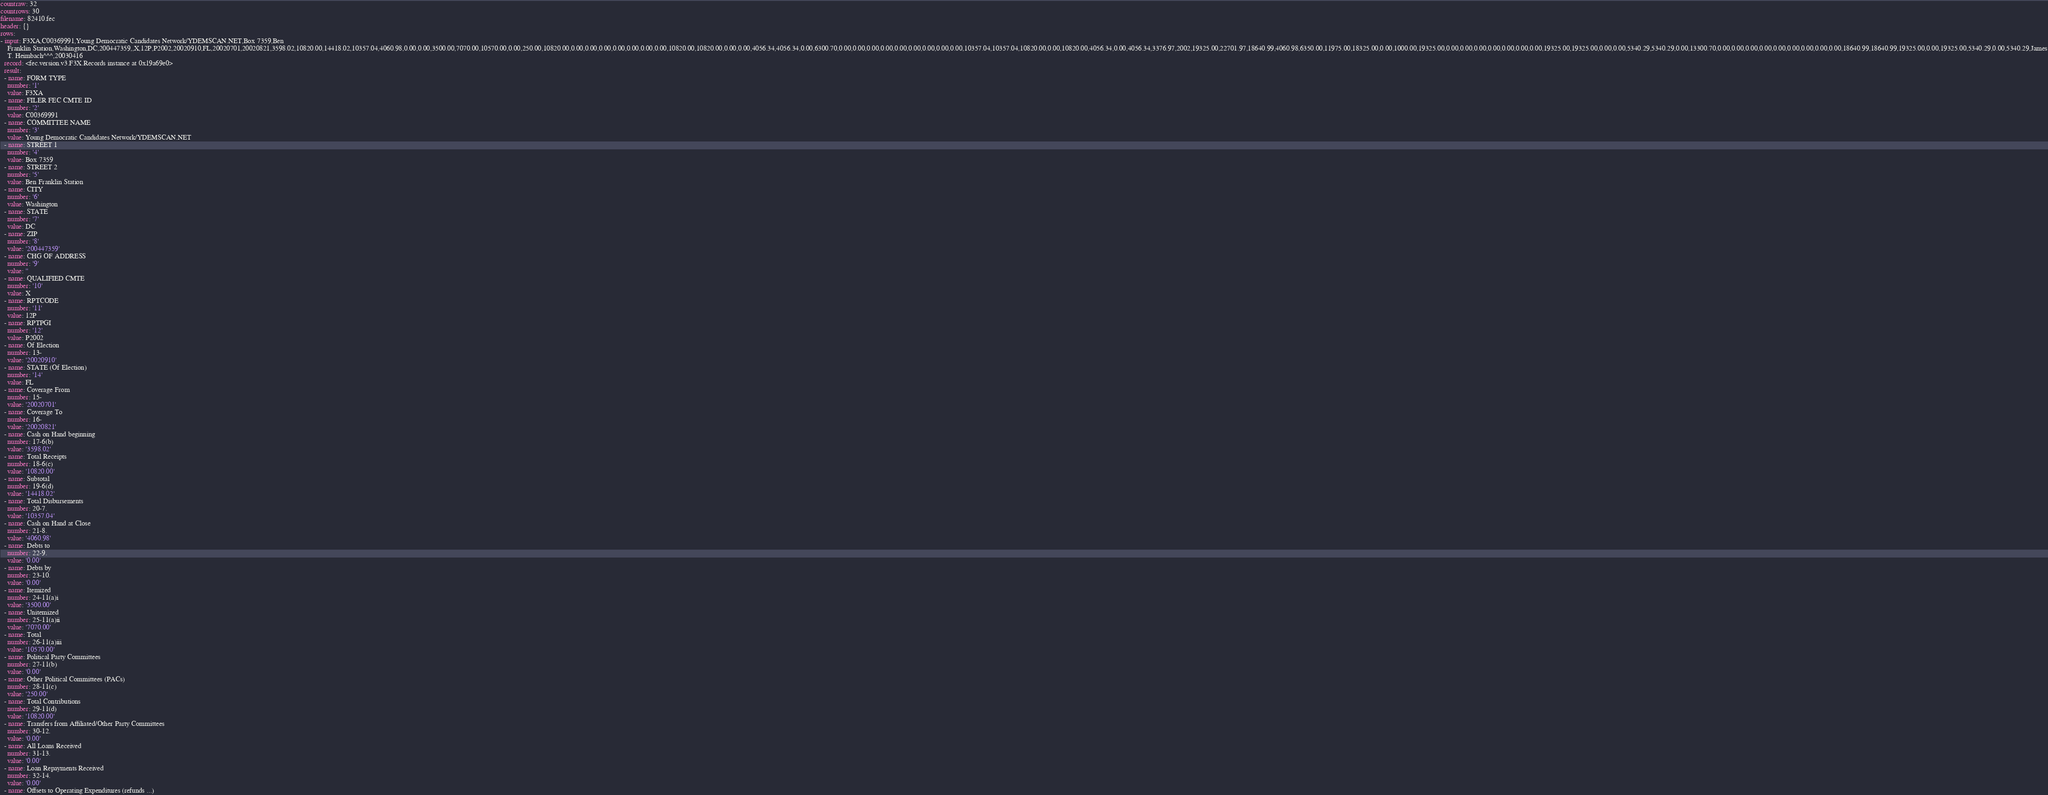<code> <loc_0><loc_0><loc_500><loc_500><_YAML_>countraw: 32
countrows: 30
filename: 82410.fec
header: {}
rows:
- input: F3XA,C00369991,Young Democratic Candidates Network/YDEMSCAN.NET,Box 7359,Ben
    Franklin Station,Washington,DC,200447359,,X,12P,P2002,20020910,FL,20020701,20020821,3598.02,10820.00,14418.02,10357.04,4060.98,0.00,0.00,3500.00,7070.00,10570.00,0.00,250.00,10820.00,0.00,0.00,0.00,0.00,0.00,0.00,0.00,10820.00,10820.00,0.00,0.00,4056.34,4056.34,0.00,6300.70,0.00,0.00,0.00,0.00,0.00,0.00,0.00,0.00,0.00,10357.04,10357.04,10820.00,0.00,10820.00,4056.34,0.00,4056.34,3376.97,2002,19325.00,22701.97,18640.99,4060.98,6350.00,11975.00,18325.00,0.00,1000.00,19325.00,0.00,0.00,0.00,0.00,0.00,0.00,0.00,19325.00,19325.00,0.00,0.00,5340.29,5340.29,0.00,13300.70,0.00,0.00,0.00,0.00,0.00,0.00,0.00,0.00,0.00,18640.99,18640.99,19325.00,0.00,19325.00,5340.29,0.00,5340.29,James
    T. Heimbach^^^,20030416
  record: <fec.version.v3.F3X.Records instance at 0x19a69e0>
  result:
  - name: FORM TYPE
    number: '1'
    value: F3XA
  - name: FILER FEC CMTE ID
    number: '2'
    value: C00369991
  - name: COMMITTEE NAME
    number: '3'
    value: Young Democratic Candidates Network/YDEMSCAN.NET
  - name: STREET 1
    number: '4'
    value: Box 7359
  - name: STREET 2
    number: '5'
    value: Ben Franklin Station
  - name: CITY
    number: '6'
    value: Washington
  - name: STATE
    number: '7'
    value: DC
  - name: ZIP
    number: '8'
    value: '200447359'
  - name: CHG OF ADDRESS
    number: '9'
    value: ''
  - name: QUALIFIED CMTE
    number: '10'
    value: X
  - name: RPTCODE
    number: '11'
    value: 12P
  - name: RPTPGI
    number: '12'
    value: P2002
  - name: Of Election
    number: 13-
    value: '20020910'
  - name: STATE (Of Election)
    number: '14'
    value: FL
  - name: Coverage From
    number: 15-
    value: '20020701'
  - name: Coverage To
    number: 16-
    value: '20020821'
  - name: Cash on Hand beginning
    number: 17-6(b)
    value: '3598.02'
  - name: Total Receipts
    number: 18-6(c)
    value: '10820.00'
  - name: Subtotal
    number: 19-6(d)
    value: '14418.02'
  - name: Total Disbursements
    number: 20-7.
    value: '10357.04'
  - name: Cash on Hand at Close
    number: 21-8.
    value: '4060.98'
  - name: Debts to
    number: 22-9.
    value: '0.00'
  - name: Debts by
    number: 23-10.
    value: '0.00'
  - name: Itemized
    number: 24-11(a)i
    value: '3500.00'
  - name: Unitemized
    number: 25-11(a)ii
    value: '7070.00'
  - name: Total
    number: 26-11(a)iii
    value: '10570.00'
  - name: Political Party Committees
    number: 27-11(b)
    value: '0.00'
  - name: Other Political Committees (PACs)
    number: 28-11(c)
    value: '250.00'
  - name: Total Contributions
    number: 29-11(d)
    value: '10820.00'
  - name: Transfers from Affiliated/Other Party Committees
    number: 30-12.
    value: '0.00'
  - name: All Loans Received
    number: 31-13.
    value: '0.00'
  - name: Loan Repayments Received
    number: 32-14.
    value: '0.00'
  - name: Offsets to Operating Expenditures (refunds ...)</code> 